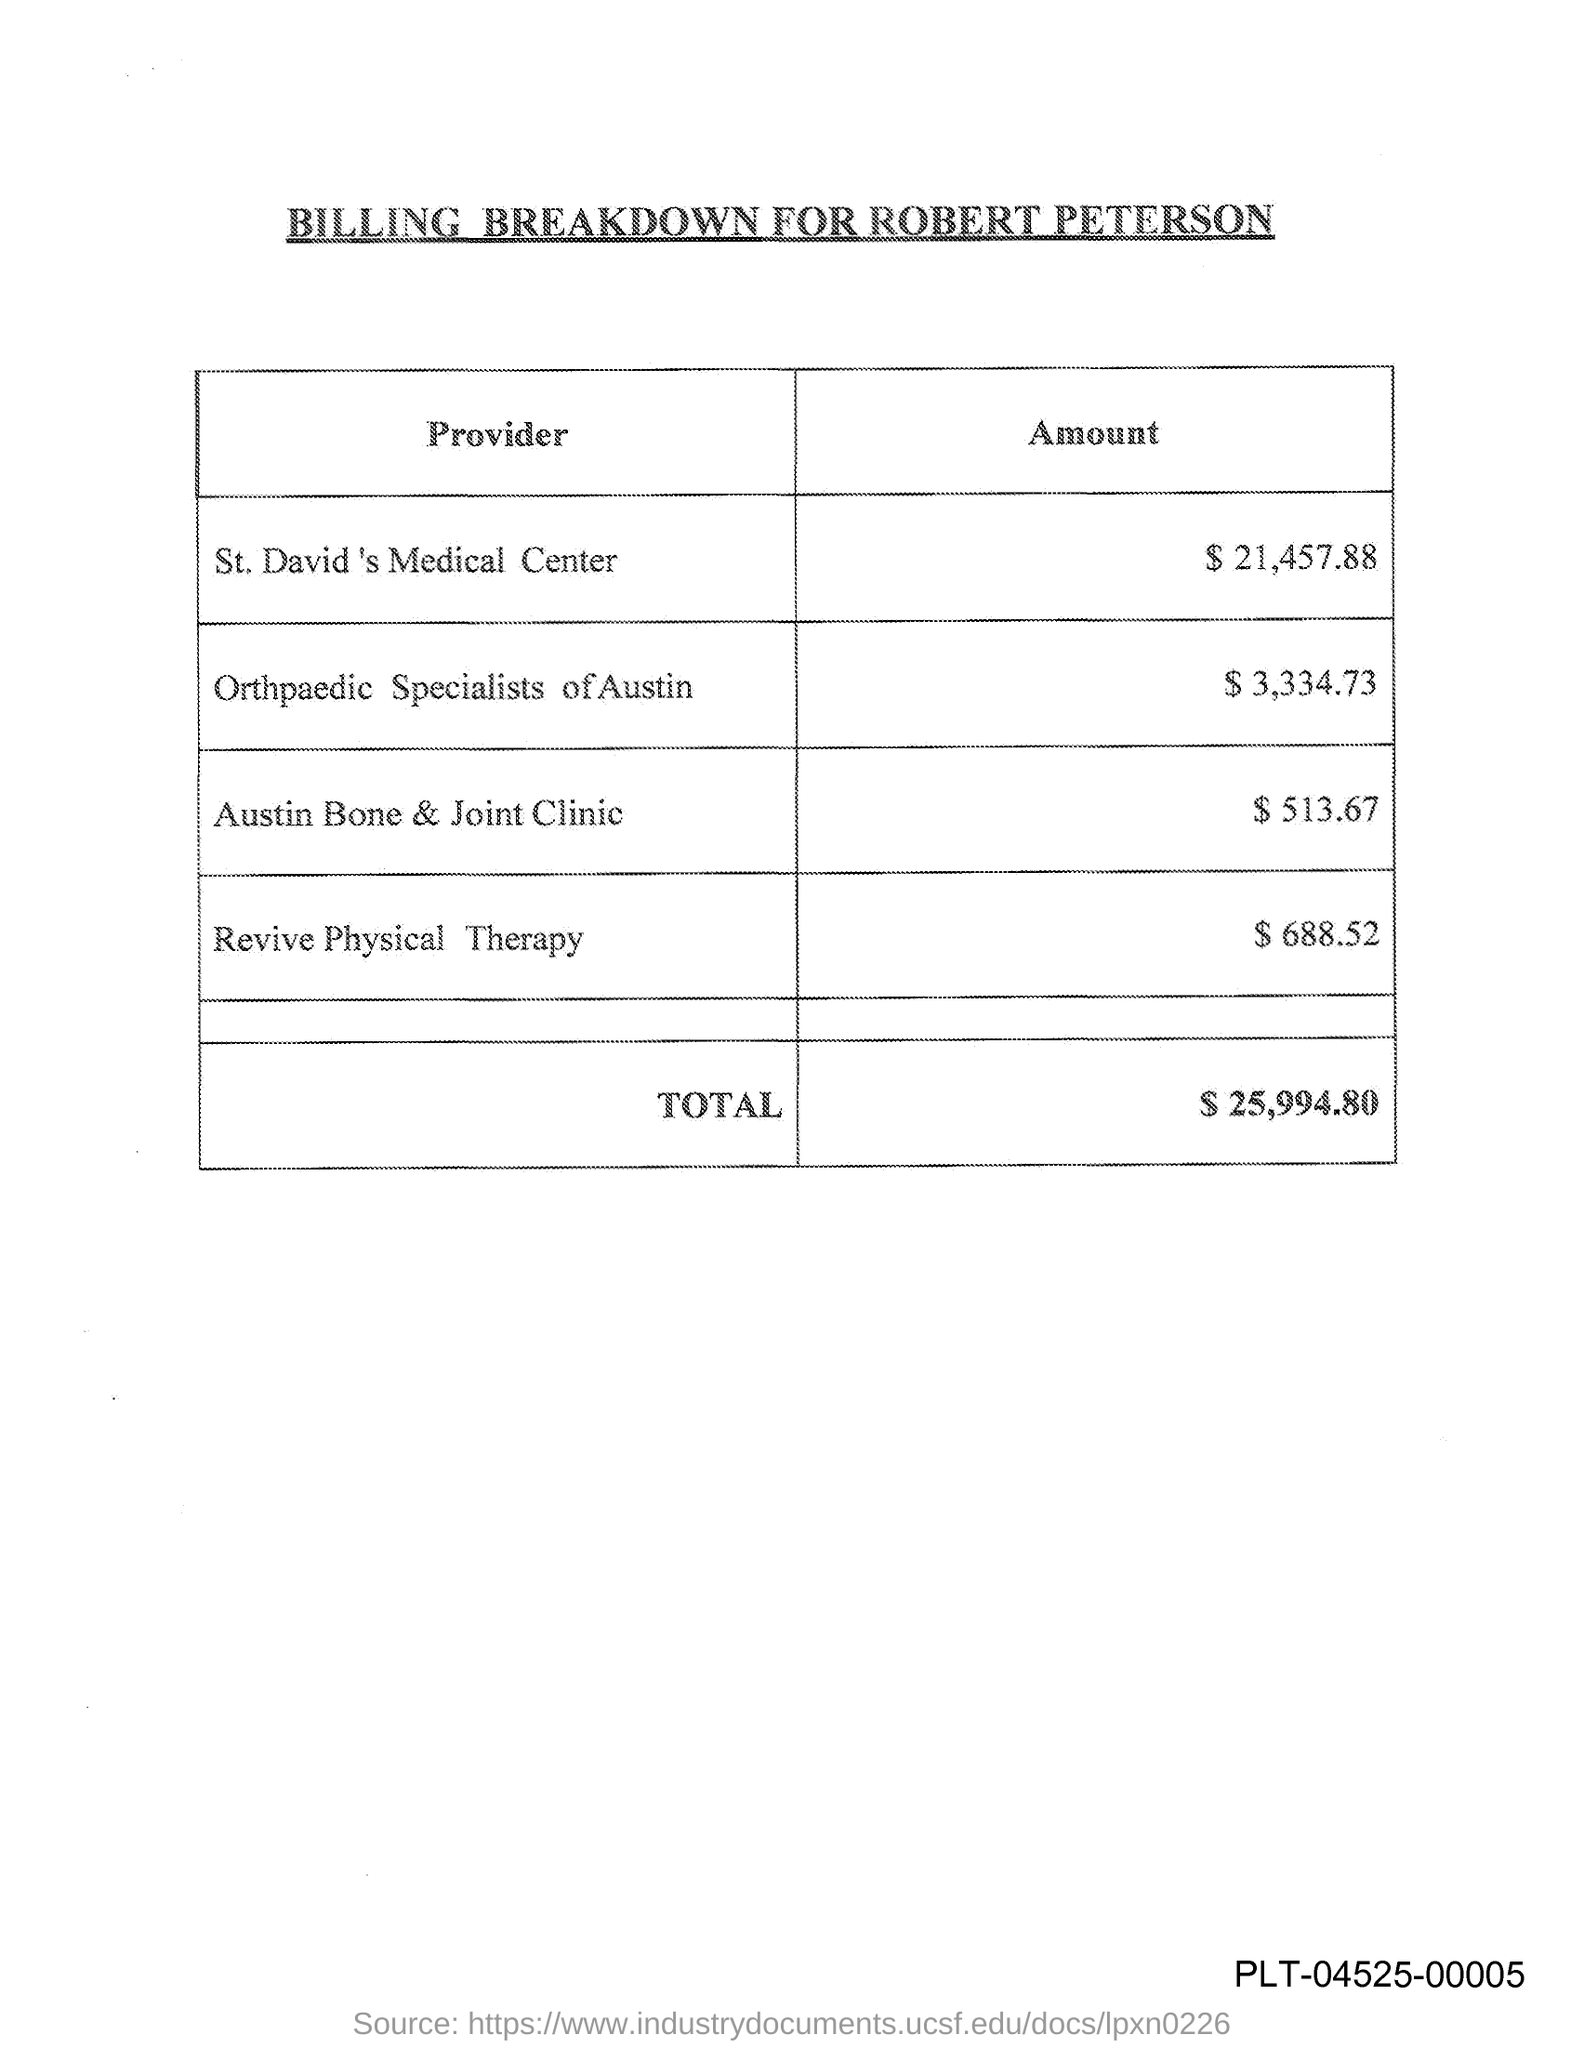Outline some significant characteristics in this image. This document is titled 'BILLING BREAKDOWN FOR ROBERT PETERSON.' The amount provided by St. David's Medical Center is $21,457.88. Orthopaedic Specialists of Austin has provided an amount of $3,334.73. The amount provided by Revive Physical Therapy is $688.52. The amount provided by Austin Bone & Joint Clinic is $513.67. 